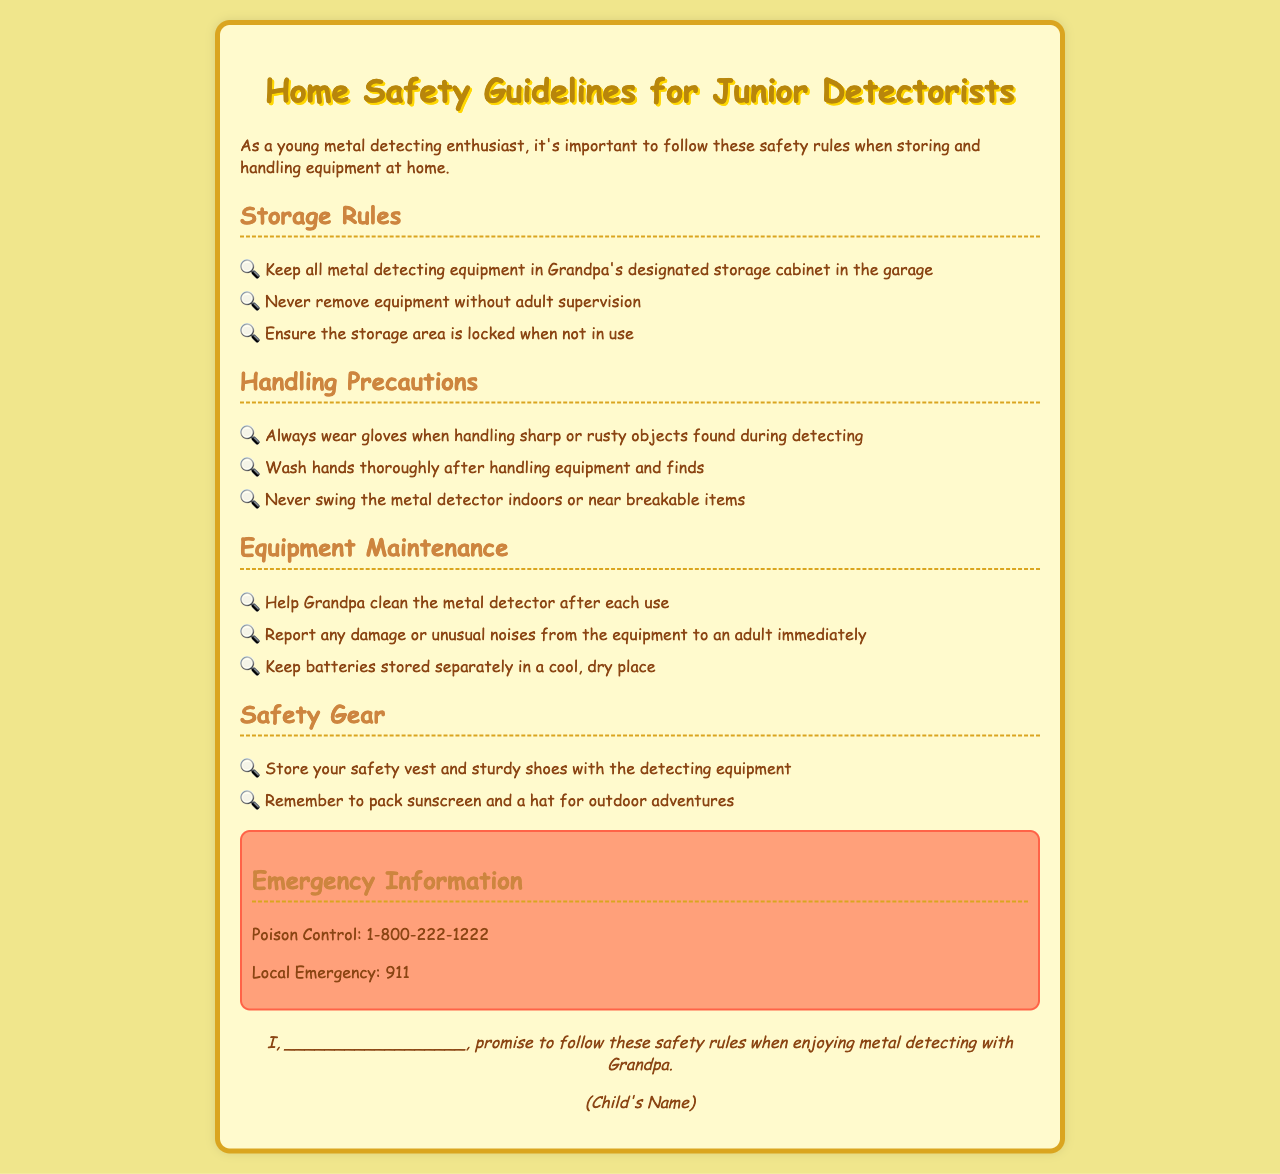What are the storage rules? The document lists specific storage rules regarding metal detecting equipment, including where to keep it and who can remove it.
Answer: Keep all metal detecting equipment in Grandpa's designated storage cabinet in the garage What should you always wear when handling sharp objects? The document emphasizes the importance of wearing protective gear, specifically for safety while handling finds.
Answer: Gloves What number should you call for poison control? The document provides emergency contact information for poison control.
Answer: 1-800-222-1222 What should you help Grandpa with after each use? The document specifies a maintenance task for the equipment that a child should assist with.
Answer: Clean the metal detector What is a precaution to take before swings the metal detector? The document advises caution regarding the environment when using detecting equipment.
Answer: Never swing the metal detector indoors or near breakable items Why is it important to keep the storage area locked? The document implies the necessity of security for the equipment and safety at home.
Answer: To ensure safety What does the child promise to follow? The document includes a commitment from the child to adhere to safety rules while detecting with Grandpa.
Answer: Safety rules What should be packed for outdoor adventures? The document mentions specific items that should be included for safety and protection during metal detecting outings.
Answer: Sunscreen and a hat 